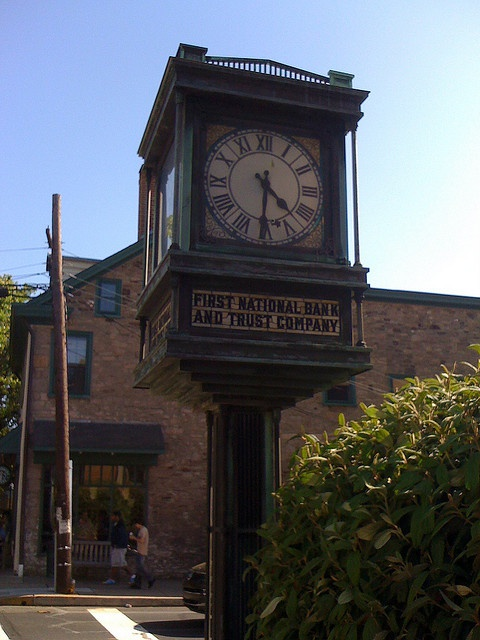Describe the objects in this image and their specific colors. I can see clock in darkgray, gray, and black tones, people in darkgray and black tones, car in darkgray, black, gray, and maroon tones, people in darkgray, black, maroon, and brown tones, and people in black, maroon, and darkgray tones in this image. 